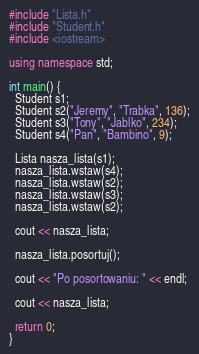<code> <loc_0><loc_0><loc_500><loc_500><_C++_>#include "Lista.h"
#include "Student.h"
#include <iostream>

using namespace std;

int main() {
  Student s1;
  Student s2("Jeremy", "Trabka", 136);
  Student s3("Tony", "Jablko", 234);
  Student s4("Pan", "Bambino", 9);

  Lista nasza_lista(s1);
  nasza_lista.wstaw(s4);
  nasza_lista.wstaw(s2);
  nasza_lista.wstaw(s3);
  nasza_lista.wstaw(s2);

  cout << nasza_lista;

  nasza_lista.posortuj();

  cout << "Po posortowaniu: " << endl;

  cout << nasza_lista;

  return 0;
}
</code> 